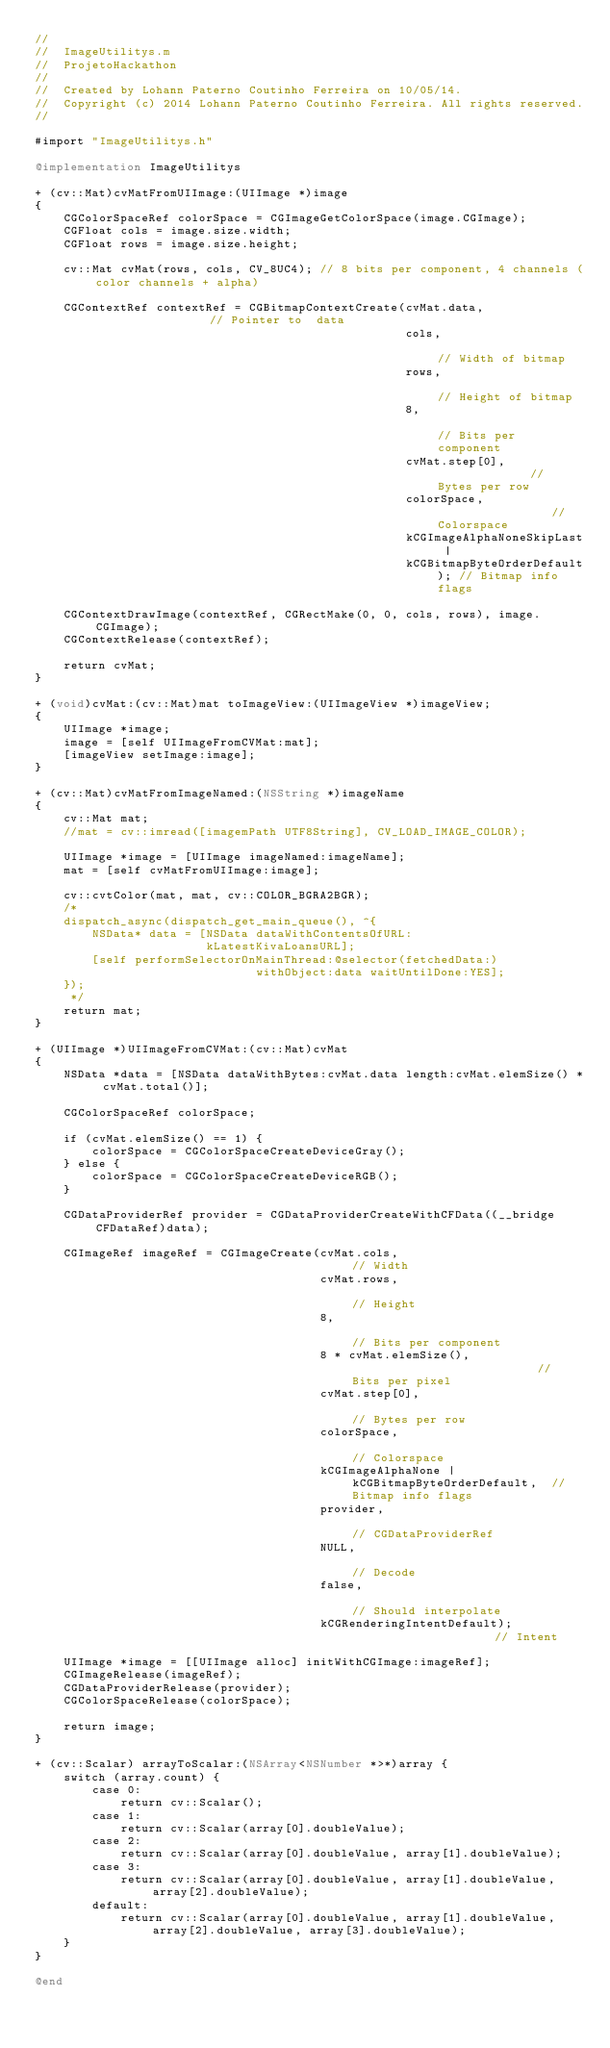<code> <loc_0><loc_0><loc_500><loc_500><_ObjectiveC_>//
//  ImageUtilitys.m
//  ProjetoHackathon
//
//  Created by Lohann Paterno Coutinho Ferreira on 10/05/14.
//  Copyright (c) 2014 Lohann Paterno Coutinho Ferreira. All rights reserved.
//

#import "ImageUtilitys.h"

@implementation ImageUtilitys

+ (cv::Mat)cvMatFromUIImage:(UIImage *)image
{
    CGColorSpaceRef colorSpace = CGImageGetColorSpace(image.CGImage);
    CGFloat cols = image.size.width;
    CGFloat rows = image.size.height;
    
    cv::Mat cvMat(rows, cols, CV_8UC4); // 8 bits per component, 4 channels (color channels + alpha)
    
    CGContextRef contextRef = CGBitmapContextCreate(cvMat.data,                 // Pointer to  data
                                                    cols,                       // Width of bitmap
                                                    rows,                       // Height of bitmap
                                                    8,                          // Bits per component
                                                    cvMat.step[0],              // Bytes per row
                                                    colorSpace,                 // Colorspace
                                                    kCGImageAlphaNoneSkipLast |
                                                    kCGBitmapByteOrderDefault); // Bitmap info flags
    
    CGContextDrawImage(contextRef, CGRectMake(0, 0, cols, rows), image.CGImage);
    CGContextRelease(contextRef);
    
    return cvMat;
}

+ (void)cvMat:(cv::Mat)mat toImageView:(UIImageView *)imageView;
{
    UIImage *image;
    image = [self UIImageFromCVMat:mat];
    [imageView setImage:image];
}

+ (cv::Mat)cvMatFromImageNamed:(NSString *)imageName
{
    cv::Mat mat;
    //mat = cv::imread([imagemPath UTF8String], CV_LOAD_IMAGE_COLOR);
    
    UIImage *image = [UIImage imageNamed:imageName];
    mat = [self cvMatFromUIImage:image];
    
    cv::cvtColor(mat, mat, cv::COLOR_BGRA2BGR);
    /*
    dispatch_async(dispatch_get_main_queue(), ^{
        NSData* data = [NSData dataWithContentsOfURL:
                        kLatestKivaLoansURL];
        [self performSelectorOnMainThread:@selector(fetchedData:)
                               withObject:data waitUntilDone:YES];
    });
     */
    return mat;
}

+ (UIImage *)UIImageFromCVMat:(cv::Mat)cvMat
{
    NSData *data = [NSData dataWithBytes:cvMat.data length:cvMat.elemSize() * cvMat.total()];
    
    CGColorSpaceRef colorSpace;
    
    if (cvMat.elemSize() == 1) {
        colorSpace = CGColorSpaceCreateDeviceGray();
    } else {
        colorSpace = CGColorSpaceCreateDeviceRGB();
    }
    
    CGDataProviderRef provider = CGDataProviderCreateWithCFData((__bridge CFDataRef)data);
    
    CGImageRef imageRef = CGImageCreate(cvMat.cols,                                     // Width
                                        cvMat.rows,                                     // Height
                                        8,                                              // Bits per component
                                        8 * cvMat.elemSize(),                           // Bits per pixel
                                        cvMat.step[0],                                  // Bytes per row
                                        colorSpace,                                     // Colorspace
                                        kCGImageAlphaNone | kCGBitmapByteOrderDefault,  // Bitmap info flags
                                        provider,                                       // CGDataProviderRef
                                        NULL,                                           // Decode
                                        false,                                          // Should interpolate
                                        kCGRenderingIntentDefault);                     // Intent
    
    UIImage *image = [[UIImage alloc] initWithCGImage:imageRef];
    CGImageRelease(imageRef);
    CGDataProviderRelease(provider);
    CGColorSpaceRelease(colorSpace);
    
    return image;
}

+ (cv::Scalar) arrayToScalar:(NSArray<NSNumber *>*)array {
    switch (array.count) {
        case 0:
            return cv::Scalar();
        case 1:
            return cv::Scalar(array[0].doubleValue);
        case 2:
            return cv::Scalar(array[0].doubleValue, array[1].doubleValue);
        case 3:
            return cv::Scalar(array[0].doubleValue, array[1].doubleValue, array[2].doubleValue);
        default:
            return cv::Scalar(array[0].doubleValue, array[1].doubleValue, array[2].doubleValue, array[3].doubleValue);
    }
}

@end
</code> 